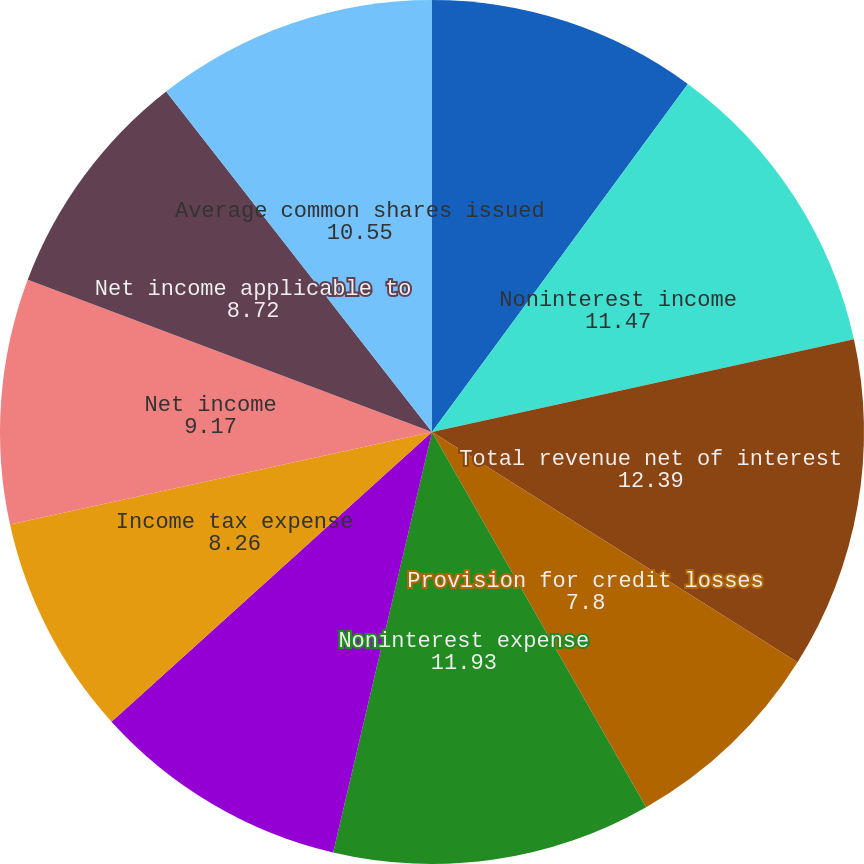<chart> <loc_0><loc_0><loc_500><loc_500><pie_chart><fcel>Net interest income<fcel>Noninterest income<fcel>Total revenue net of interest<fcel>Provision for credit losses<fcel>Noninterest expense<fcel>Income before income taxes<fcel>Income tax expense<fcel>Net income<fcel>Net income applicable to<fcel>Average common shares issued<nl><fcel>10.09%<fcel>11.47%<fcel>12.39%<fcel>7.8%<fcel>11.93%<fcel>9.63%<fcel>8.26%<fcel>9.17%<fcel>8.72%<fcel>10.55%<nl></chart> 